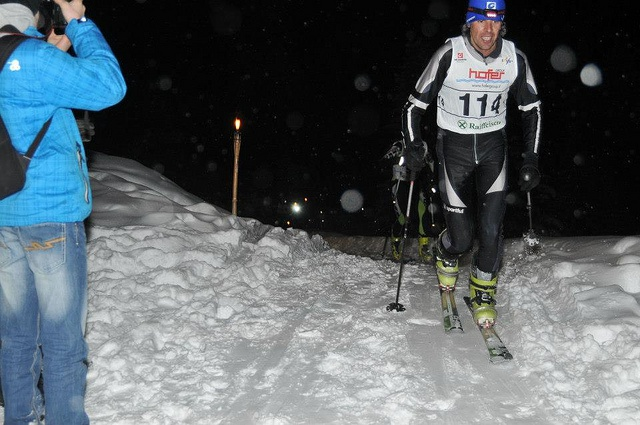Describe the objects in this image and their specific colors. I can see people in black, lightblue, gray, and darkgray tones, people in black, lightgray, darkgray, and gray tones, people in black, gray, darkgreen, and lightgray tones, skis in black, gray, and darkgray tones, and backpack in black, navy, and blue tones in this image. 